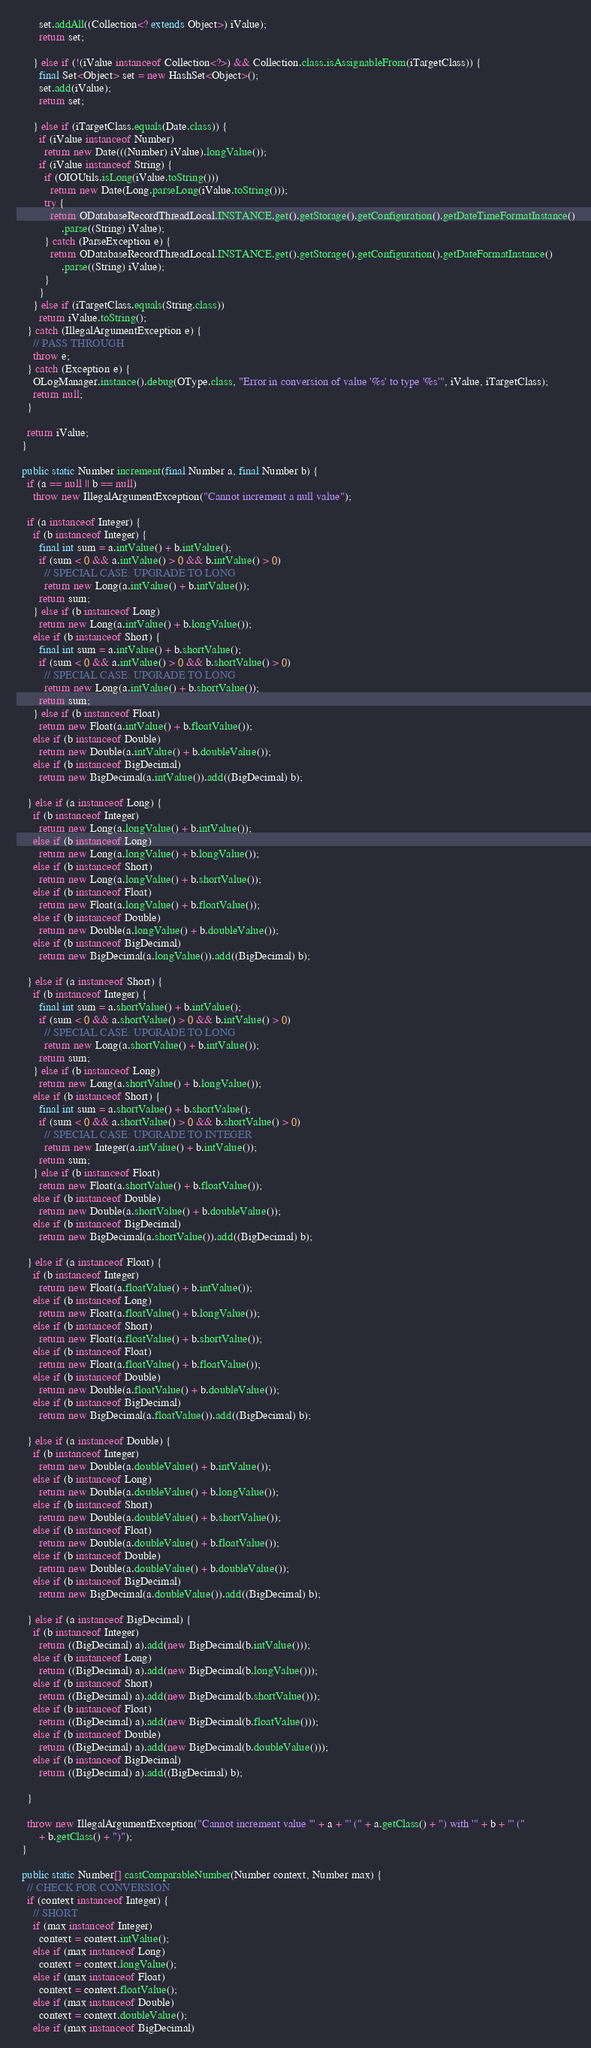Convert code to text. <code><loc_0><loc_0><loc_500><loc_500><_Java_>        set.addAll((Collection<? extends Object>) iValue);
        return set;

      } else if (!(iValue instanceof Collection<?>) && Collection.class.isAssignableFrom(iTargetClass)) {
        final Set<Object> set = new HashSet<Object>();
        set.add(iValue);
        return set;

      } else if (iTargetClass.equals(Date.class)) {
        if (iValue instanceof Number)
          return new Date(((Number) iValue).longValue());
        if (iValue instanceof String) {
          if (OIOUtils.isLong(iValue.toString()))
            return new Date(Long.parseLong(iValue.toString()));
          try {
            return ODatabaseRecordThreadLocal.INSTANCE.get().getStorage().getConfiguration().getDateTimeFormatInstance()
                .parse((String) iValue);
          } catch (ParseException e) {
            return ODatabaseRecordThreadLocal.INSTANCE.get().getStorage().getConfiguration().getDateFormatInstance()
                .parse((String) iValue);
          }
        }
      } else if (iTargetClass.equals(String.class))
        return iValue.toString();
    } catch (IllegalArgumentException e) {
      // PASS THROUGH
      throw e;
    } catch (Exception e) {
      OLogManager.instance().debug(OType.class, "Error in conversion of value '%s' to type '%s'", iValue, iTargetClass);
      return null;
    }

    return iValue;
  }

  public static Number increment(final Number a, final Number b) {
    if (a == null || b == null)
      throw new IllegalArgumentException("Cannot increment a null value");

    if (a instanceof Integer) {
      if (b instanceof Integer) {
        final int sum = a.intValue() + b.intValue();
        if (sum < 0 && a.intValue() > 0 && b.intValue() > 0)
          // SPECIAL CASE: UPGRADE TO LONG
          return new Long(a.intValue() + b.intValue());
        return sum;
      } else if (b instanceof Long)
        return new Long(a.intValue() + b.longValue());
      else if (b instanceof Short) {
        final int sum = a.intValue() + b.shortValue();
        if (sum < 0 && a.intValue() > 0 && b.shortValue() > 0)
          // SPECIAL CASE: UPGRADE TO LONG
          return new Long(a.intValue() + b.shortValue());
        return sum;
      } else if (b instanceof Float)
        return new Float(a.intValue() + b.floatValue());
      else if (b instanceof Double)
        return new Double(a.intValue() + b.doubleValue());
      else if (b instanceof BigDecimal)
        return new BigDecimal(a.intValue()).add((BigDecimal) b);

    } else if (a instanceof Long) {
      if (b instanceof Integer)
        return new Long(a.longValue() + b.intValue());
      else if (b instanceof Long)
        return new Long(a.longValue() + b.longValue());
      else if (b instanceof Short)
        return new Long(a.longValue() + b.shortValue());
      else if (b instanceof Float)
        return new Float(a.longValue() + b.floatValue());
      else if (b instanceof Double)
        return new Double(a.longValue() + b.doubleValue());
      else if (b instanceof BigDecimal)
        return new BigDecimal(a.longValue()).add((BigDecimal) b);

    } else if (a instanceof Short) {
      if (b instanceof Integer) {
        final int sum = a.shortValue() + b.intValue();
        if (sum < 0 && a.shortValue() > 0 && b.intValue() > 0)
          // SPECIAL CASE: UPGRADE TO LONG
          return new Long(a.shortValue() + b.intValue());
        return sum;
      } else if (b instanceof Long)
        return new Long(a.shortValue() + b.longValue());
      else if (b instanceof Short) {
        final int sum = a.shortValue() + b.shortValue();
        if (sum < 0 && a.shortValue() > 0 && b.shortValue() > 0)
          // SPECIAL CASE: UPGRADE TO INTEGER
          return new Integer(a.intValue() + b.intValue());
        return sum;
      } else if (b instanceof Float)
        return new Float(a.shortValue() + b.floatValue());
      else if (b instanceof Double)
        return new Double(a.shortValue() + b.doubleValue());
      else if (b instanceof BigDecimal)
        return new BigDecimal(a.shortValue()).add((BigDecimal) b);

    } else if (a instanceof Float) {
      if (b instanceof Integer)
        return new Float(a.floatValue() + b.intValue());
      else if (b instanceof Long)
        return new Float(a.floatValue() + b.longValue());
      else if (b instanceof Short)
        return new Float(a.floatValue() + b.shortValue());
      else if (b instanceof Float)
        return new Float(a.floatValue() + b.floatValue());
      else if (b instanceof Double)
        return new Double(a.floatValue() + b.doubleValue());
      else if (b instanceof BigDecimal)
        return new BigDecimal(a.floatValue()).add((BigDecimal) b);

    } else if (a instanceof Double) {
      if (b instanceof Integer)
        return new Double(a.doubleValue() + b.intValue());
      else if (b instanceof Long)
        return new Double(a.doubleValue() + b.longValue());
      else if (b instanceof Short)
        return new Double(a.doubleValue() + b.shortValue());
      else if (b instanceof Float)
        return new Double(a.doubleValue() + b.floatValue());
      else if (b instanceof Double)
        return new Double(a.doubleValue() + b.doubleValue());
      else if (b instanceof BigDecimal)
        return new BigDecimal(a.doubleValue()).add((BigDecimal) b);

    } else if (a instanceof BigDecimal) {
      if (b instanceof Integer)
        return ((BigDecimal) a).add(new BigDecimal(b.intValue()));
      else if (b instanceof Long)
        return ((BigDecimal) a).add(new BigDecimal(b.longValue()));
      else if (b instanceof Short)
        return ((BigDecimal) a).add(new BigDecimal(b.shortValue()));
      else if (b instanceof Float)
        return ((BigDecimal) a).add(new BigDecimal(b.floatValue()));
      else if (b instanceof Double)
        return ((BigDecimal) a).add(new BigDecimal(b.doubleValue()));
      else if (b instanceof BigDecimal)
        return ((BigDecimal) a).add((BigDecimal) b);

    }

    throw new IllegalArgumentException("Cannot increment value '" + a + "' (" + a.getClass() + ") with '" + b + "' ("
        + b.getClass() + ")");
  }

  public static Number[] castComparableNumber(Number context, Number max) {
    // CHECK FOR CONVERSION
    if (context instanceof Integer) {
      // SHORT
      if (max instanceof Integer)
        context = context.intValue();
      else if (max instanceof Long)
        context = context.longValue();
      else if (max instanceof Float)
        context = context.floatValue();
      else if (max instanceof Double)
        context = context.doubleValue();
      else if (max instanceof BigDecimal)</code> 